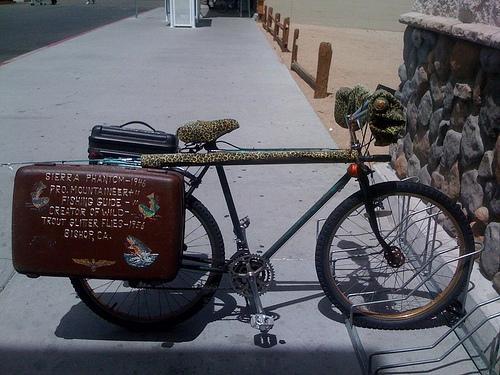What design is the bike seat?

Choices:
A) leopard print
B) stripes
C) zebra print
D) plaid leopard print 